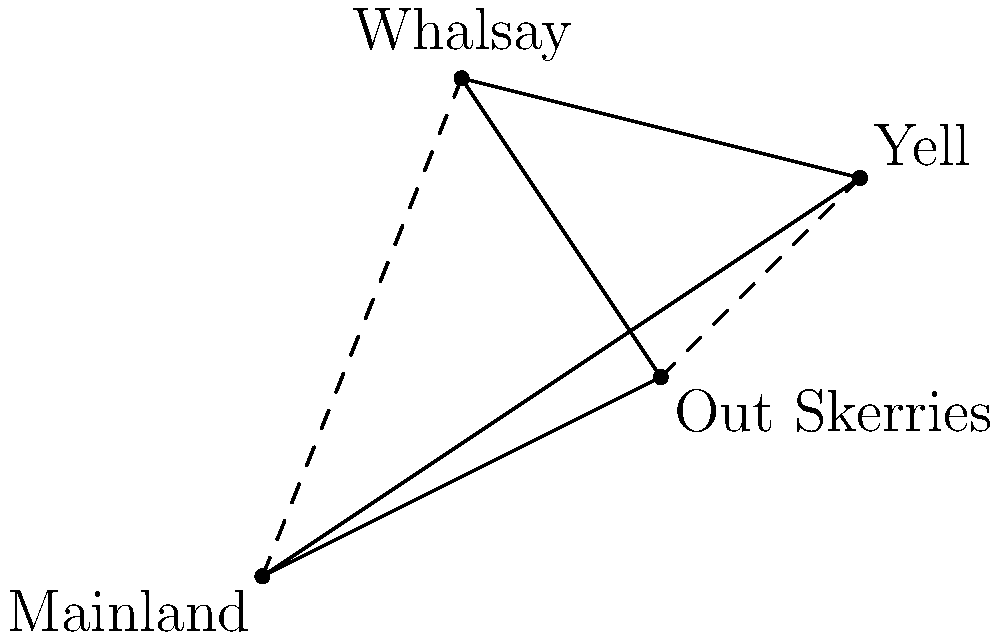A ferry service connects four Shetland islands: Mainland, Out Skerries, Whalsay, and Yell. The distances and directions between the islands are represented by vectors in nautical miles. The vector from Mainland to Out Skerries is $\vec{a} = 4\hat{i} + 2\hat{j}$, from Out Skerries to Whalsay is $\vec{b} = -2\hat{i} + 3\hat{j}$, and from Whalsay to Yell is $\vec{c} = 4\hat{i} - \hat{j}$. What is the most efficient route (in terms of distance) from Mainland to Yell, and what is its corresponding vector? To find the most efficient route from Mainland to Yell, we need to compare two possible paths:

1. Direct route: Mainland → Out Skerries → Yell
2. Indirect route: Mainland → Whalsay → Yell

Let's calculate each route:

1. Direct route:
   Vector from Mainland to Out Skerries: $\vec{a} = 4\hat{i} + 2\hat{j}$
   Vector from Out Skerries to Yell: $\vec{d} = \vec{b} + \vec{c} = (-2\hat{i} + 3\hat{j}) + (4\hat{i} - \hat{j}) = 2\hat{i} + 2\hat{j}$
   Total vector: $\vec{a} + \vec{d} = (4\hat{i} + 2\hat{j}) + (2\hat{i} + 2\hat{j}) = 6\hat{i} + 4\hat{j}$

2. Indirect route:
   Vector from Mainland to Whalsay: $\vec{e} = \vec{a} + \vec{b} = (4\hat{i} + 2\hat{j}) + (-2\hat{i} + 3\hat{j}) = 2\hat{i} + 5\hat{j}$
   Vector from Whalsay to Yell: $\vec{c} = 4\hat{i} - \hat{j}$
   Total vector: $\vec{e} + \vec{c} = (2\hat{i} + 5\hat{j}) + (4\hat{i} - \hat{j}) = 6\hat{i} + 4\hat{j}$

Both routes result in the same vector: $6\hat{i} + 4\hat{j}$. This means both routes are equally efficient in terms of distance.

The magnitude of this vector is:
$$\sqrt{6^2 + 4^2} = \sqrt{36 + 16} = \sqrt{52} \approx 7.21$$ nautical miles.

Therefore, the most efficient route from Mainland to Yell can be either path, and the corresponding vector is $6\hat{i} + 4\hat{j}$.
Answer: $6\hat{i} + 4\hat{j}$ 